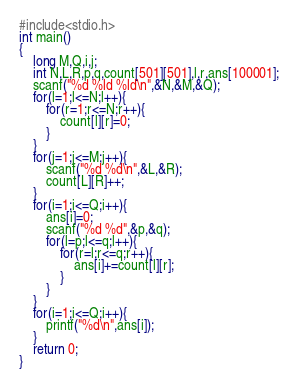<code> <loc_0><loc_0><loc_500><loc_500><_C_>#include<stdio.h>
int main()
{
	long M,Q,i,j;
	int N,L,R,p,q,count[501][501],l,r,ans[100001];
	scanf("%d %ld %ld\n",&N,&M,&Q);
	for(l=1;l<=N;l++){
		for(r=1;r<=N;r++){
			count[l][r]=0;
		}
	}
	for(j=1;j<=M;j++){
		scanf("%d %d\n",&L,&R);
		count[L][R]++;
	}
	for(i=1;i<=Q;i++){
		ans[i]=0;
		scanf("%d %d",&p,&q);
		for(l=p;l<=q;l++){
			for(r=l;r<=q;r++){
				ans[i]+=count[l][r];
			}
		}
	}
	for(i=1;i<=Q;i++){
		printf("%d\n",ans[i]);
	}
	return 0;
}
</code> 